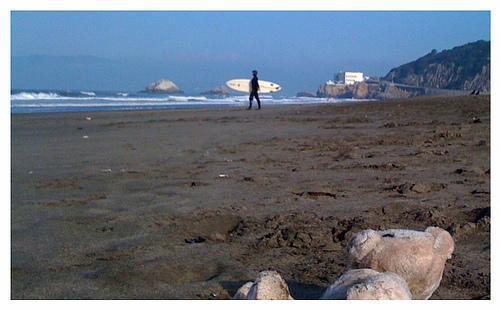How many people at the beach?
Give a very brief answer. 1. 